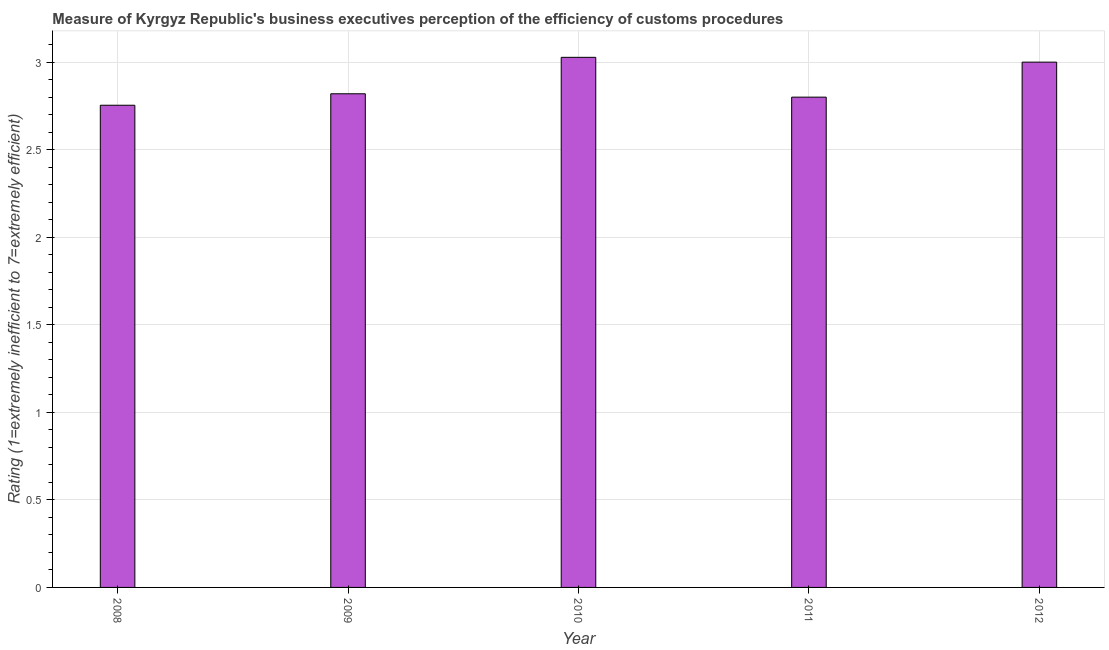Does the graph contain any zero values?
Provide a succinct answer. No. What is the title of the graph?
Keep it short and to the point. Measure of Kyrgyz Republic's business executives perception of the efficiency of customs procedures. What is the label or title of the X-axis?
Offer a terse response. Year. What is the label or title of the Y-axis?
Provide a short and direct response. Rating (1=extremely inefficient to 7=extremely efficient). Across all years, what is the maximum rating measuring burden of customs procedure?
Your answer should be compact. 3.03. Across all years, what is the minimum rating measuring burden of customs procedure?
Your answer should be compact. 2.75. What is the sum of the rating measuring burden of customs procedure?
Your answer should be compact. 14.4. What is the difference between the rating measuring burden of customs procedure in 2010 and 2011?
Offer a terse response. 0.23. What is the average rating measuring burden of customs procedure per year?
Your response must be concise. 2.88. What is the median rating measuring burden of customs procedure?
Your answer should be very brief. 2.82. Do a majority of the years between 2008 and 2011 (inclusive) have rating measuring burden of customs procedure greater than 2.3 ?
Your answer should be compact. Yes. What is the ratio of the rating measuring burden of customs procedure in 2008 to that in 2011?
Provide a short and direct response. 0.98. Is the difference between the rating measuring burden of customs procedure in 2010 and 2011 greater than the difference between any two years?
Offer a terse response. No. What is the difference between the highest and the second highest rating measuring burden of customs procedure?
Your response must be concise. 0.03. What is the difference between the highest and the lowest rating measuring burden of customs procedure?
Your response must be concise. 0.27. Are the values on the major ticks of Y-axis written in scientific E-notation?
Make the answer very short. No. What is the Rating (1=extremely inefficient to 7=extremely efficient) of 2008?
Give a very brief answer. 2.75. What is the Rating (1=extremely inefficient to 7=extremely efficient) of 2009?
Provide a succinct answer. 2.82. What is the Rating (1=extremely inefficient to 7=extremely efficient) in 2010?
Your response must be concise. 3.03. What is the Rating (1=extremely inefficient to 7=extremely efficient) of 2012?
Ensure brevity in your answer.  3. What is the difference between the Rating (1=extremely inefficient to 7=extremely efficient) in 2008 and 2009?
Give a very brief answer. -0.07. What is the difference between the Rating (1=extremely inefficient to 7=extremely efficient) in 2008 and 2010?
Offer a terse response. -0.27. What is the difference between the Rating (1=extremely inefficient to 7=extremely efficient) in 2008 and 2011?
Provide a succinct answer. -0.05. What is the difference between the Rating (1=extremely inefficient to 7=extremely efficient) in 2008 and 2012?
Give a very brief answer. -0.25. What is the difference between the Rating (1=extremely inefficient to 7=extremely efficient) in 2009 and 2010?
Give a very brief answer. -0.21. What is the difference between the Rating (1=extremely inefficient to 7=extremely efficient) in 2009 and 2011?
Keep it short and to the point. 0.02. What is the difference between the Rating (1=extremely inefficient to 7=extremely efficient) in 2009 and 2012?
Offer a very short reply. -0.18. What is the difference between the Rating (1=extremely inefficient to 7=extremely efficient) in 2010 and 2011?
Your response must be concise. 0.23. What is the difference between the Rating (1=extremely inefficient to 7=extremely efficient) in 2010 and 2012?
Ensure brevity in your answer.  0.03. What is the difference between the Rating (1=extremely inefficient to 7=extremely efficient) in 2011 and 2012?
Offer a very short reply. -0.2. What is the ratio of the Rating (1=extremely inefficient to 7=extremely efficient) in 2008 to that in 2010?
Your response must be concise. 0.91. What is the ratio of the Rating (1=extremely inefficient to 7=extremely efficient) in 2008 to that in 2011?
Your answer should be very brief. 0.98. What is the ratio of the Rating (1=extremely inefficient to 7=extremely efficient) in 2008 to that in 2012?
Offer a terse response. 0.92. What is the ratio of the Rating (1=extremely inefficient to 7=extremely efficient) in 2010 to that in 2011?
Provide a succinct answer. 1.08. What is the ratio of the Rating (1=extremely inefficient to 7=extremely efficient) in 2010 to that in 2012?
Make the answer very short. 1.01. What is the ratio of the Rating (1=extremely inefficient to 7=extremely efficient) in 2011 to that in 2012?
Provide a succinct answer. 0.93. 